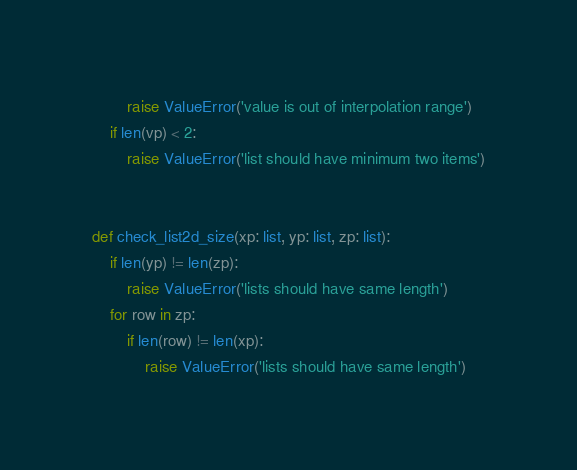<code> <loc_0><loc_0><loc_500><loc_500><_Python_>        raise ValueError('value is out of interpolation range')
    if len(vp) < 2:
        raise ValueError('list should have minimum two items')


def check_list2d_size(xp: list, yp: list, zp: list):
    if len(yp) != len(zp):
        raise ValueError('lists should have same length')
    for row in zp:
        if len(row) != len(xp):
            raise ValueError('lists should have same length')
</code> 